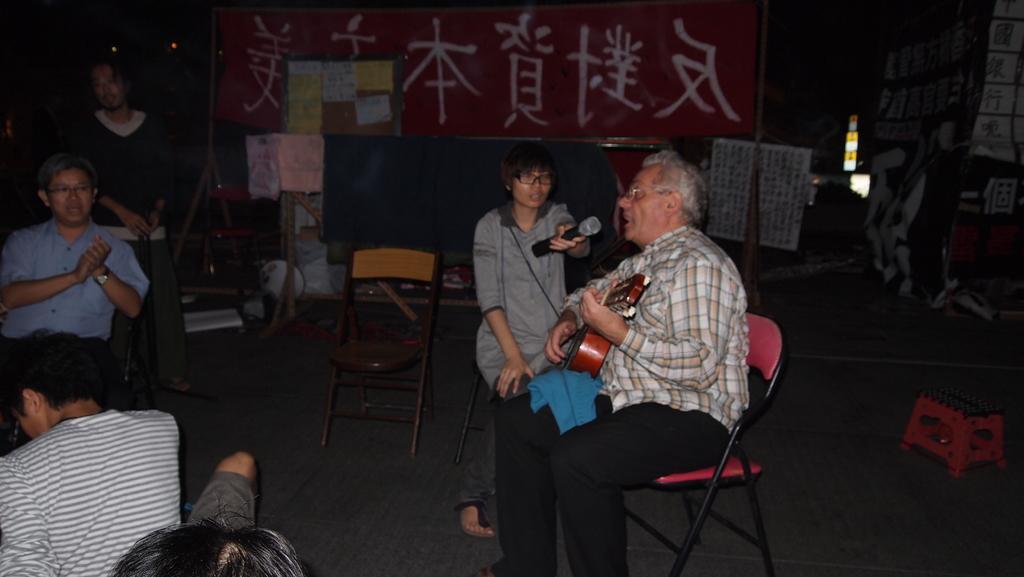Describe this image in one or two sentences. In this picture I can see a person standing, three persons sitting on the chairs, a person holding a guitar, another person holding a mike, there are two persons, there are papers, boards, a stool and some other objects. 